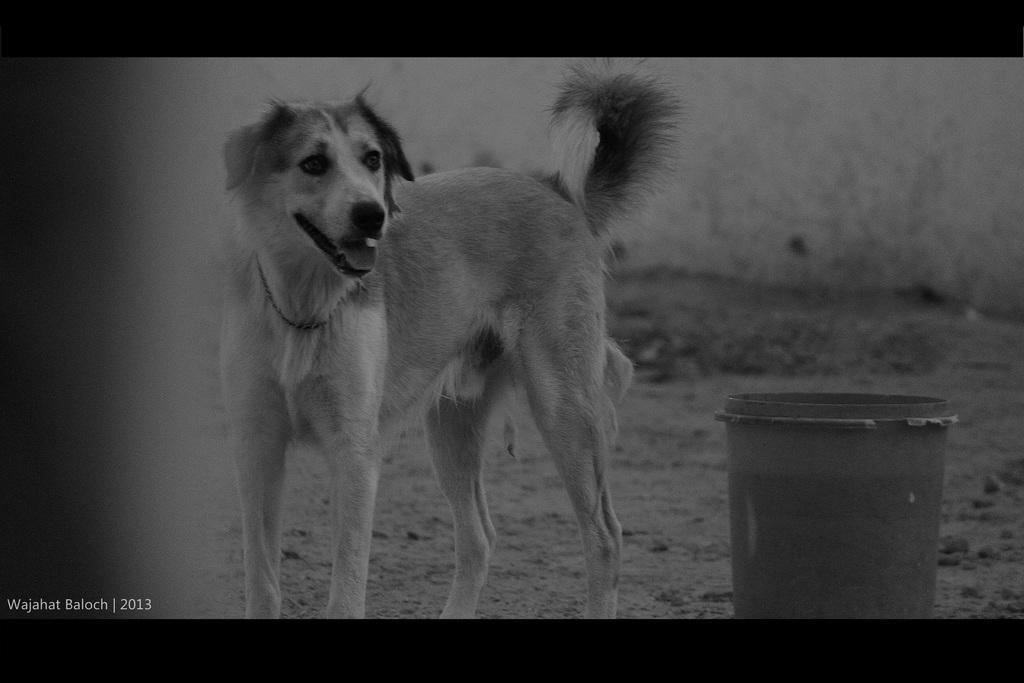Describe this image in one or two sentences. In this black and white image, we can see a dog. There is a bucket in the bottom right of the image. In the background, image is blurred. 